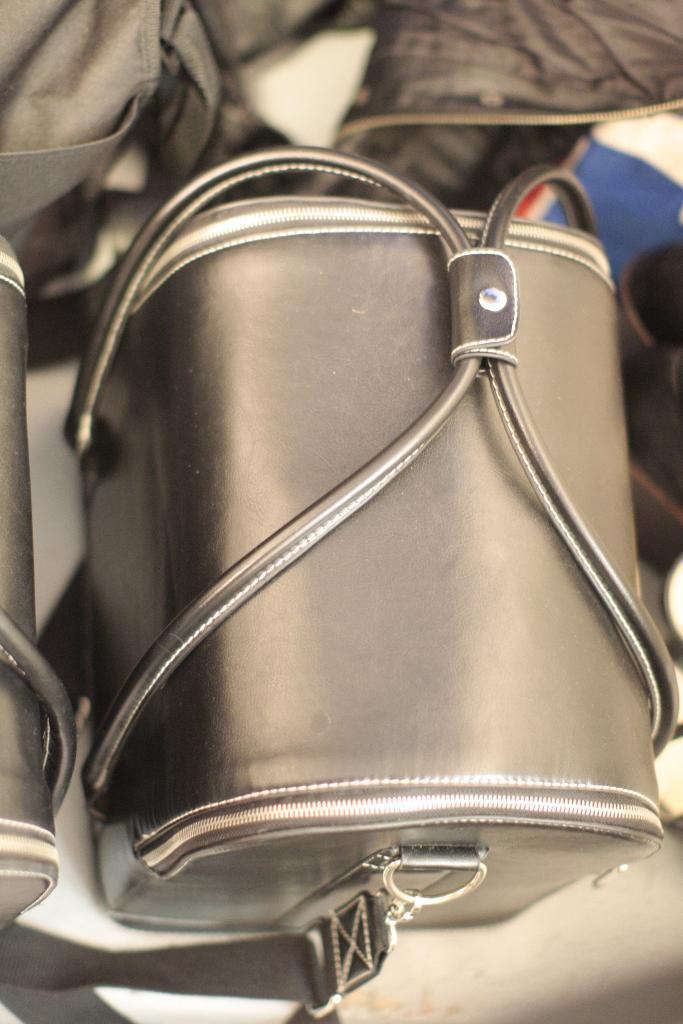What type of accessory is visible in the image? There is a handbag in the image. How many fangs can be seen on the handbag in the image? There are no fangs present on the handbag in the image. What year does the handbag represent in the image? The year is not mentioned or depicted in the image, so it cannot be determined. 